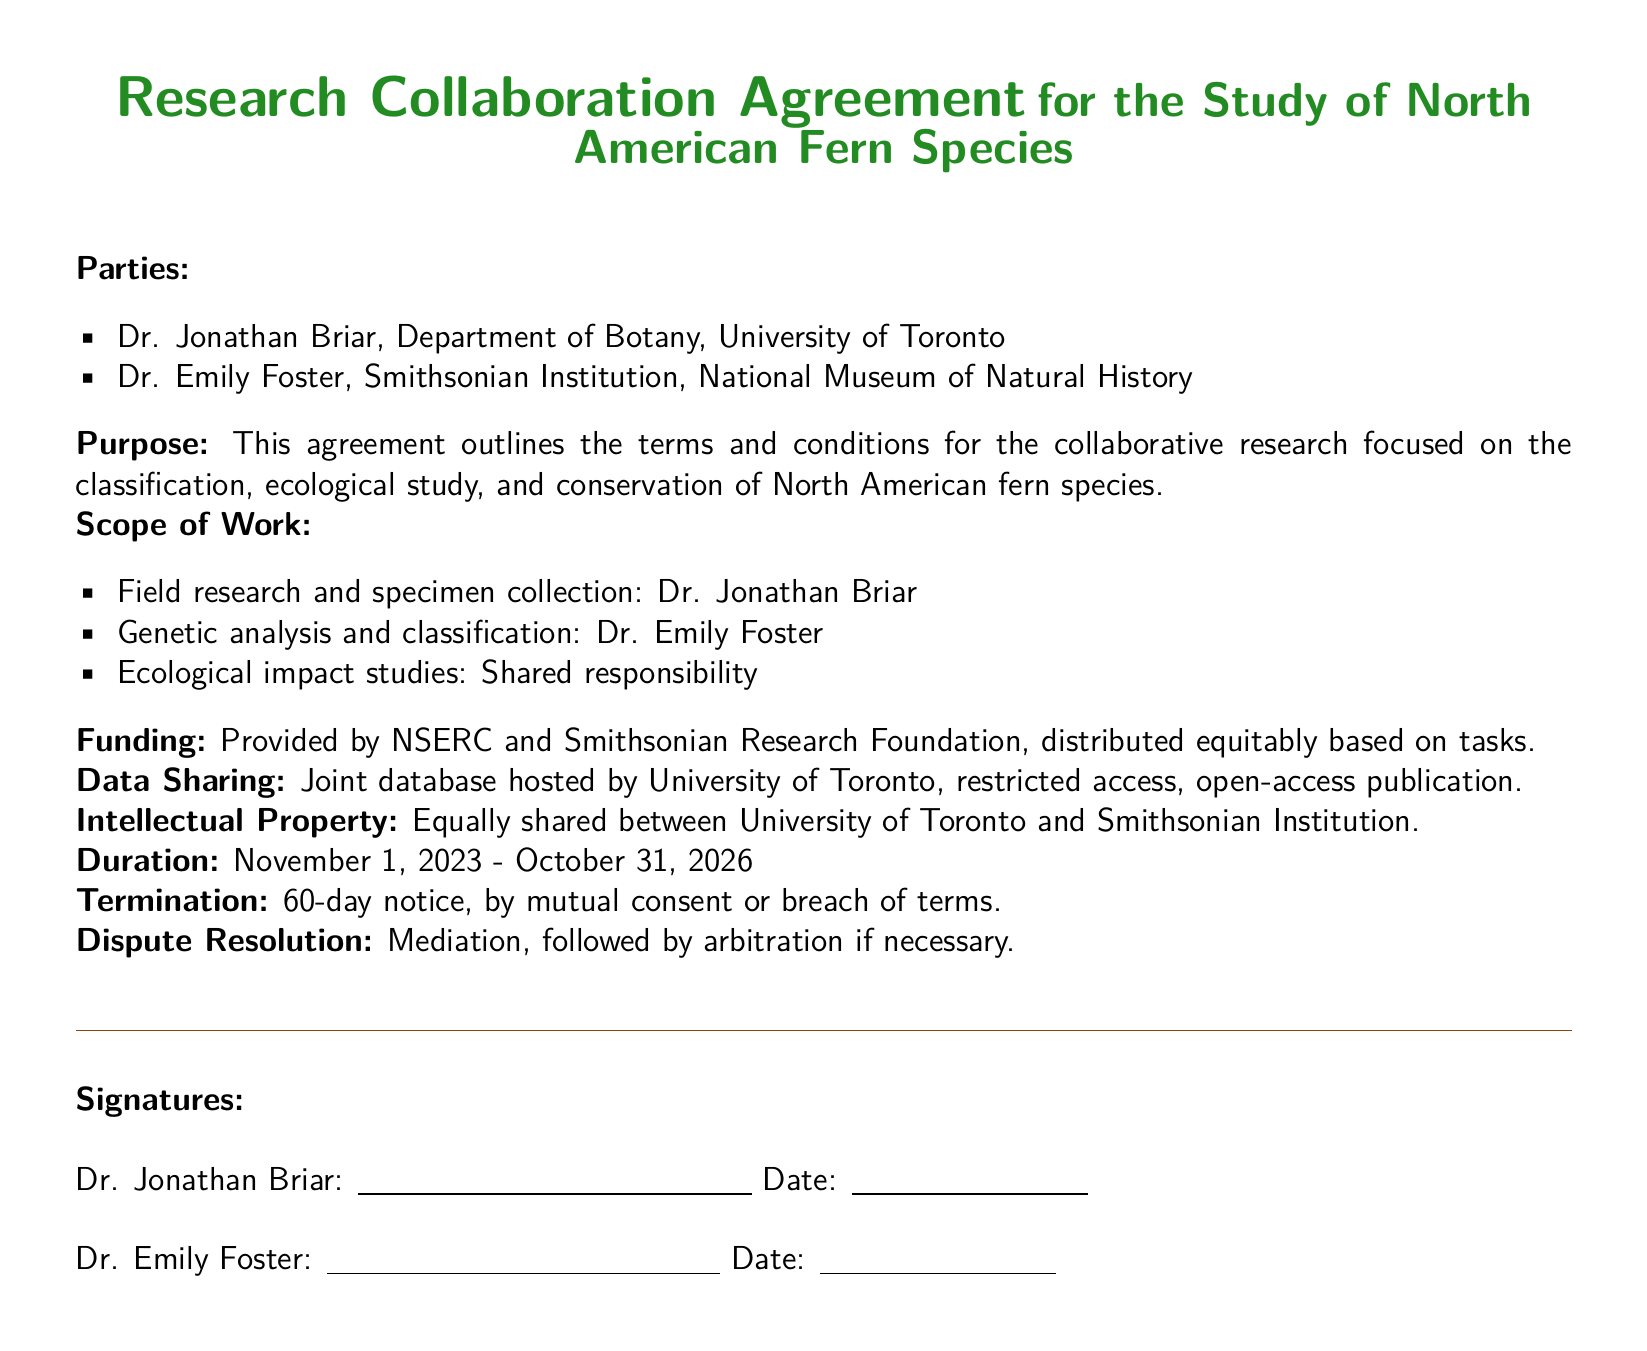What are the names of the parties involved? The parties involved in the agreement are listed at the beginning of the document as Dr. Jonathan Briar and Dr. Emily Foster.
Answer: Dr. Jonathan Briar, Dr. Emily Foster What is the purpose of the agreement? The purpose is explicitly stated to be focused on classification, ecological study, and conservation of North American fern species.
Answer: Collaborative research on North American fern species What is the duration of the agreement? The duration is specified as starting on November 1, 2023, and ending on October 31, 2026.
Answer: November 1, 2023 - October 31, 2026 Who is responsible for genetic analysis? The document allocates specific tasks, and Dr. Emily Foster is named as responsible for genetic analysis.
Answer: Dr. Emily Foster How will the funding be distributed? Funding is described to be distributed equitably based on tasks, provided by specified sources.
Answer: Equitably based on tasks What method is mentioned for dispute resolution? The agreement specifies mediation followed by arbitration as the method for resolving disputes.
Answer: Mediation, followed by arbitration What is the shared responsibility in this collaboration? The document mentions ecological impact studies as a shared responsibility of the parties.
Answer: Ecological impact studies What type of publication is allowed for the data? The data sharing section specifies that there is a provision for open-access publication.
Answer: Open-access publication 